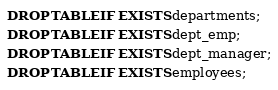Convert code to text. <code><loc_0><loc_0><loc_500><loc_500><_SQL_>DROP TABLE IF EXISTS departments;
DROP TABLE IF EXISTS dept_emp;
DROP TABLE IF EXISTS dept_manager;
DROP TABLE IF EXISTS employees;</code> 